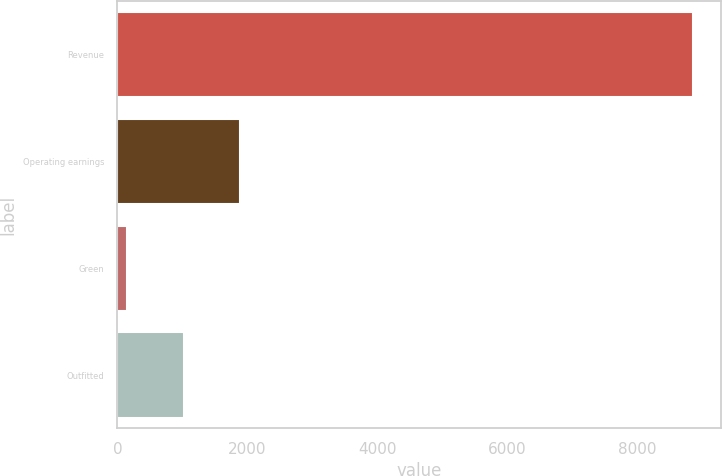Convert chart to OTSL. <chart><loc_0><loc_0><loc_500><loc_500><bar_chart><fcel>Revenue<fcel>Operating earnings<fcel>Green<fcel>Outfitted<nl><fcel>8851<fcel>1887.8<fcel>147<fcel>1017.4<nl></chart> 